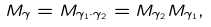<formula> <loc_0><loc_0><loc_500><loc_500>M _ { \gamma } = M _ { \gamma _ { 1 } \cdot \gamma _ { 2 } } = M _ { \gamma _ { 2 } } M _ { \gamma _ { 1 } } ,</formula> 